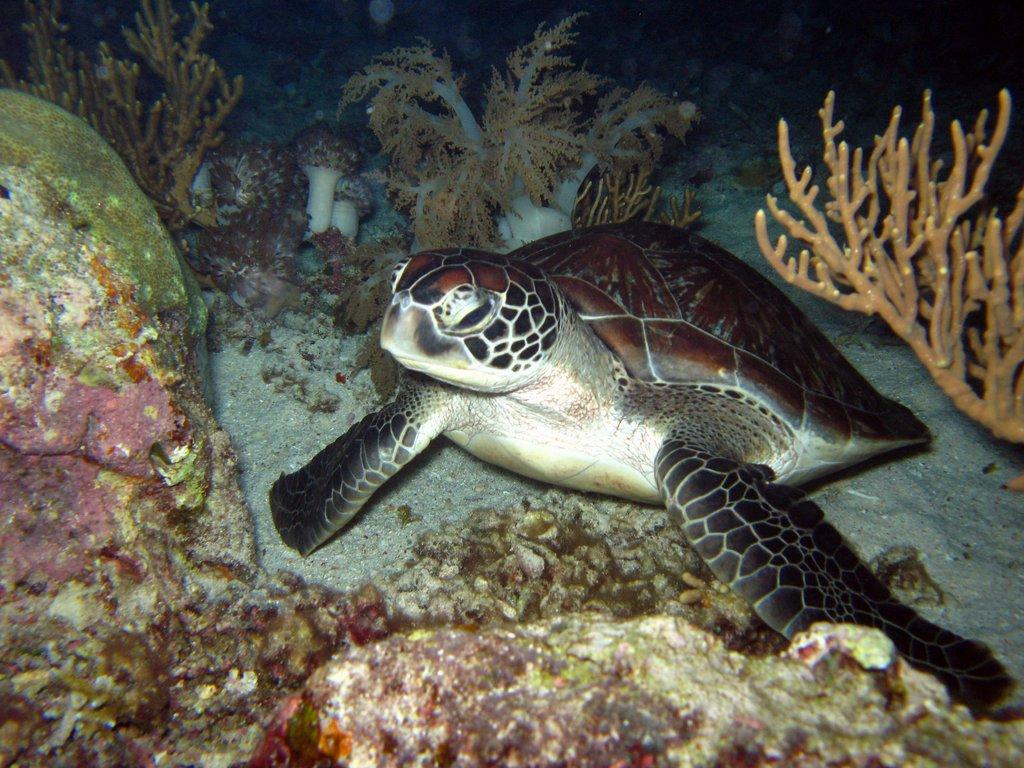What type of animal is in the image? There is a sea turtle in the image. Can you describe the setting of the image? The image depicts an underwater environment. What type of mine can be seen in the image? There is no mine present in the image; it features a sea turtle in an underwater environment. How many kittens are swimming with the sea turtle in the image? There are no kittens present in the image; it only features a sea turtle in an underwater environment. 